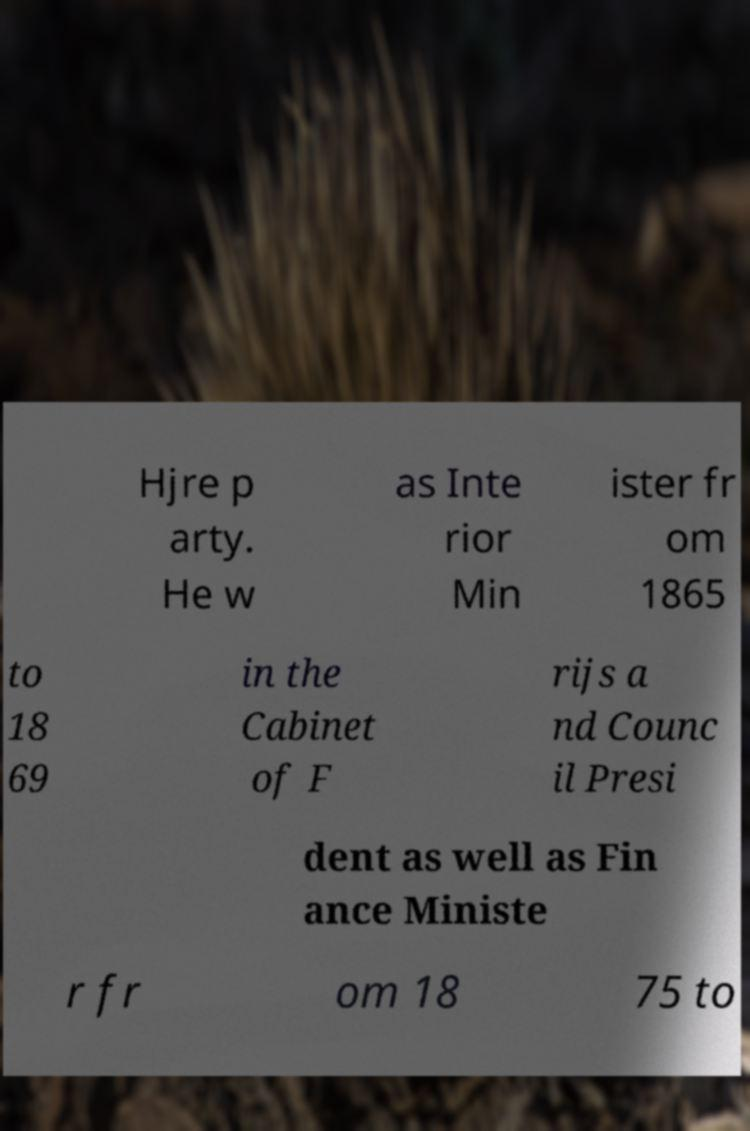Could you extract and type out the text from this image? Hjre p arty. He w as Inte rior Min ister fr om 1865 to 18 69 in the Cabinet of F rijs a nd Counc il Presi dent as well as Fin ance Ministe r fr om 18 75 to 